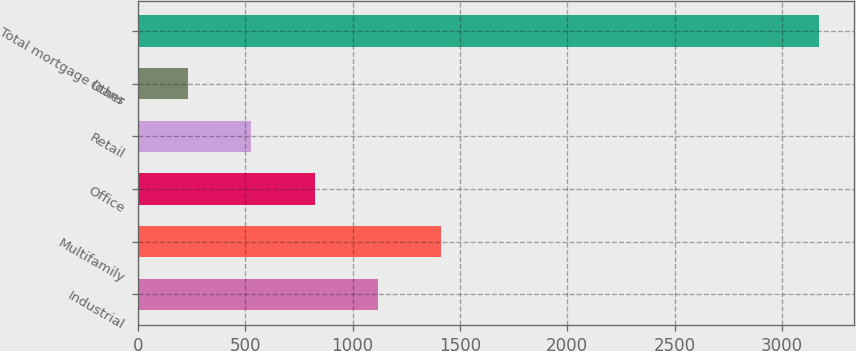Convert chart to OTSL. <chart><loc_0><loc_0><loc_500><loc_500><bar_chart><fcel>Industrial<fcel>Multifamily<fcel>Office<fcel>Retail<fcel>Other<fcel>Total mortgage loans<nl><fcel>1116.3<fcel>1410.4<fcel>822.2<fcel>528.1<fcel>234<fcel>3175<nl></chart> 